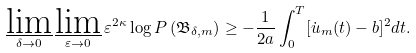Convert formula to latex. <formula><loc_0><loc_0><loc_500><loc_500>\varliminf _ { \delta \to 0 } \varliminf _ { \varepsilon \to 0 } \varepsilon ^ { 2 \kappa } \log P \left ( \mathfrak { B } _ { \delta , m } \right ) \geq - \frac { 1 } { 2 a } \int _ { 0 } ^ { T } [ \dot { u } _ { m } ( t ) - b ] ^ { 2 } d t .</formula> 